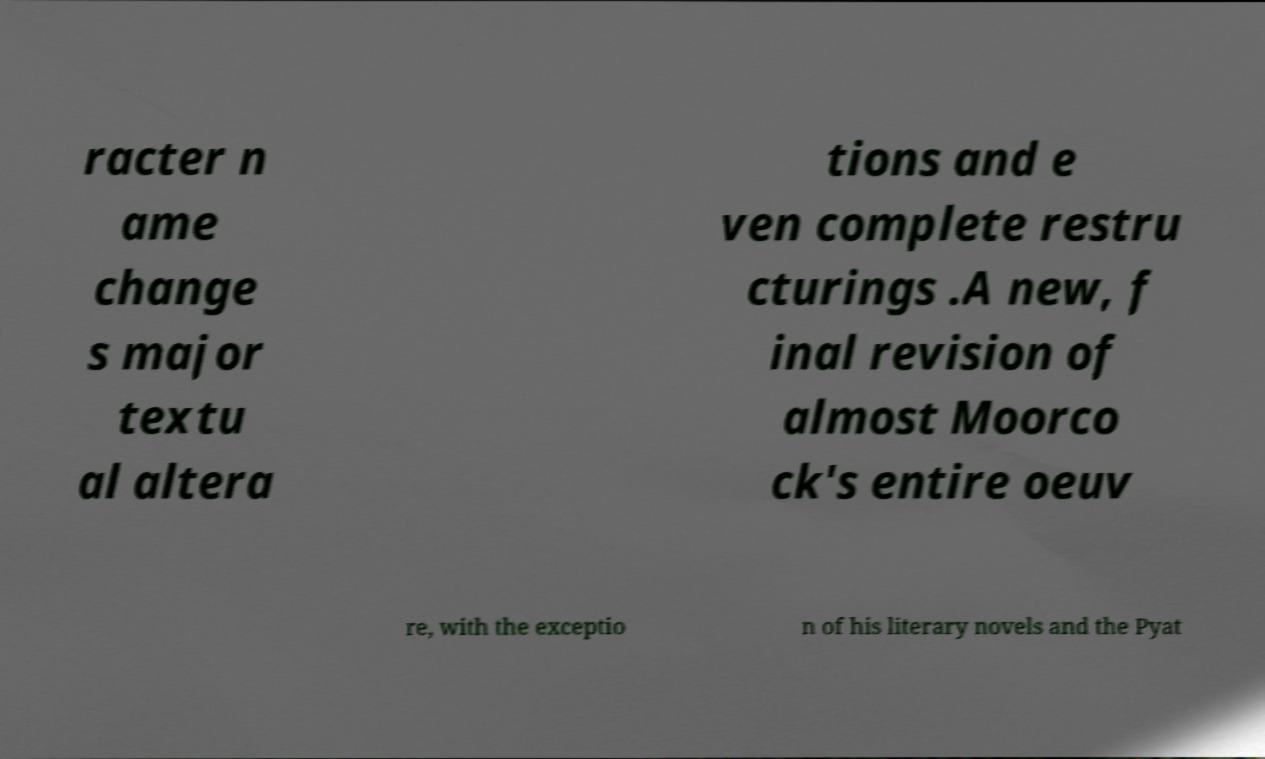Could you assist in decoding the text presented in this image and type it out clearly? racter n ame change s major textu al altera tions and e ven complete restru cturings .A new, f inal revision of almost Moorco ck's entire oeuv re, with the exceptio n of his literary novels and the Pyat 